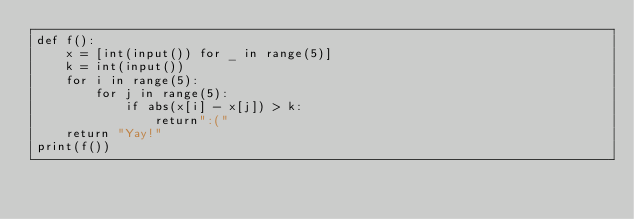<code> <loc_0><loc_0><loc_500><loc_500><_Python_>def f():
    x = [int(input()) for _ in range(5)]
    k = int(input())
    for i in range(5):
        for j in range(5):
            if abs(x[i] - x[j]) > k:
                return":("
    return "Yay!"
print(f())</code> 